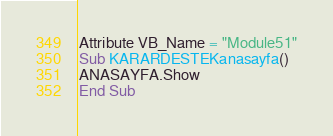<code> <loc_0><loc_0><loc_500><loc_500><_VisualBasic_>Attribute VB_Name = "Module51"
Sub KARARDESTEKanasayfa()
ANASAYFA.Show
End Sub
</code> 